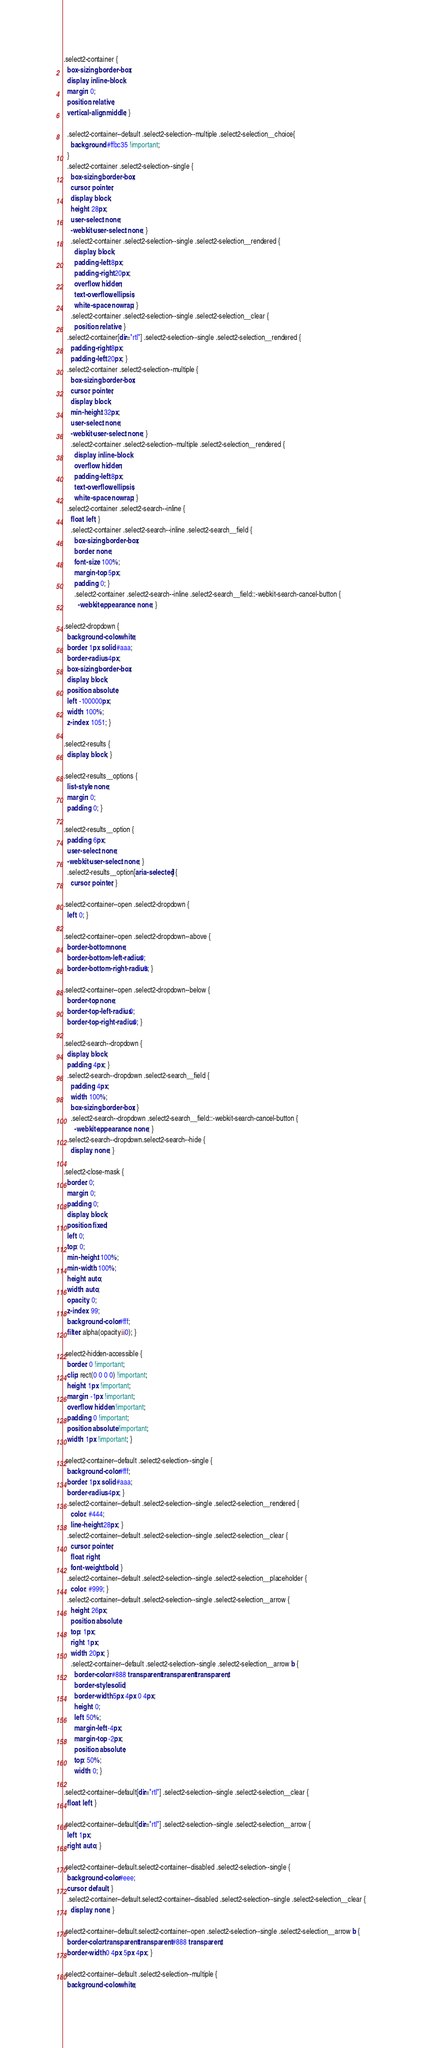Convert code to text. <code><loc_0><loc_0><loc_500><loc_500><_CSS_>.select2-container {
  box-sizing: border-box;
  display: inline-block;
  margin: 0;
  position: relative;
  vertical-align: middle; }

  .select2-container--default .select2-selection--multiple .select2-selection__choice{
    background: #ffbc35 !important;
  }
  .select2-container .select2-selection--single {
    box-sizing: border-box;
    cursor: pointer;
    display: block;
    height: 28px;
    user-select: none;
    -webkit-user-select: none; }
    .select2-container .select2-selection--single .select2-selection__rendered {
      display: block;
      padding-left: 8px;
      padding-right: 20px;
      overflow: hidden;
      text-overflow: ellipsis;
      white-space: nowrap; }
    .select2-container .select2-selection--single .select2-selection__clear {
      position: relative; }
  .select2-container[dir="rtl"] .select2-selection--single .select2-selection__rendered {
    padding-right: 8px;
    padding-left: 20px; }
  .select2-container .select2-selection--multiple {
    box-sizing: border-box;
    cursor: pointer;
    display: block;
    min-height: 32px;
    user-select: none;
    -webkit-user-select: none; }
    .select2-container .select2-selection--multiple .select2-selection__rendered {
      display: inline-block;
      overflow: hidden;
      padding-left: 8px;
      text-overflow: ellipsis;
      white-space: nowrap; }
  .select2-container .select2-search--inline {
    float: left; }
    .select2-container .select2-search--inline .select2-search__field {
      box-sizing: border-box;
      border: none;
      font-size: 100%;
      margin-top: 5px;
      padding: 0; }
      .select2-container .select2-search--inline .select2-search__field::-webkit-search-cancel-button {
        -webkit-appearance: none; }

.select2-dropdown {
  background-color: white;
  border: 1px solid #aaa;
  border-radius: 4px;
  box-sizing: border-box;
  display: block;
  position: absolute;
  left: -100000px;
  width: 100%;
  z-index: 1051; }

.select2-results {
  display: block; }

.select2-results__options {
  list-style: none;
  margin: 0;
  padding: 0; }

.select2-results__option {
  padding: 6px;
  user-select: none;
  -webkit-user-select: none; }
  .select2-results__option[aria-selected] {
    cursor: pointer; }

.select2-container--open .select2-dropdown {
  left: 0; }

.select2-container--open .select2-dropdown--above {
  border-bottom: none;
  border-bottom-left-radius: 0;
  border-bottom-right-radius: 0; }

.select2-container--open .select2-dropdown--below {
  border-top: none;
  border-top-left-radius: 0;
  border-top-right-radius: 0; }

.select2-search--dropdown {
  display: block;
  padding: 4px; }
  .select2-search--dropdown .select2-search__field {
    padding: 4px;
    width: 100%;
    box-sizing: border-box; }
    .select2-search--dropdown .select2-search__field::-webkit-search-cancel-button {
      -webkit-appearance: none; }
  .select2-search--dropdown.select2-search--hide {
    display: none; }

.select2-close-mask {
  border: 0;
  margin: 0;
  padding: 0;
  display: block;
  position: fixed;
  left: 0;
  top: 0;
  min-height: 100%;
  min-width: 100%;
  height: auto;
  width: auto;
  opacity: 0;
  z-index: 99;
  background-color: #fff;
  filter: alpha(opacity=0); }

.select2-hidden-accessible {
  border: 0 !important;
  clip: rect(0 0 0 0) !important;
  height: 1px !important;
  margin: -1px !important;
  overflow: hidden !important;
  padding: 0 !important;
  position: absolute !important;
  width: 1px !important; }

.select2-container--default .select2-selection--single {
  background-color: #fff;
  border: 1px solid #aaa;
  border-radius: 4px; }
  .select2-container--default .select2-selection--single .select2-selection__rendered {
    color: #444;
    line-height: 28px; }
  .select2-container--default .select2-selection--single .select2-selection__clear {
    cursor: pointer;
    float: right;
    font-weight: bold; }
  .select2-container--default .select2-selection--single .select2-selection__placeholder {
    color: #999; }
  .select2-container--default .select2-selection--single .select2-selection__arrow {
    height: 26px;
    position: absolute;
    top: 1px;
    right: 1px;
    width: 20px; }
    .select2-container--default .select2-selection--single .select2-selection__arrow b {
      border-color: #888 transparent transparent transparent;
      border-style: solid;
      border-width: 5px 4px 0 4px;
      height: 0;
      left: 50%;
      margin-left: -4px;
      margin-top: -2px;
      position: absolute;
      top: 50%;
      width: 0; }

.select2-container--default[dir="rtl"] .select2-selection--single .select2-selection__clear {
  float: left; }

.select2-container--default[dir="rtl"] .select2-selection--single .select2-selection__arrow {
  left: 1px;
  right: auto; }

.select2-container--default.select2-container--disabled .select2-selection--single {
  background-color: #eee;
  cursor: default; }
  .select2-container--default.select2-container--disabled .select2-selection--single .select2-selection__clear {
    display: none; }

.select2-container--default.select2-container--open .select2-selection--single .select2-selection__arrow b {
  border-color: transparent transparent #888 transparent;
  border-width: 0 4px 5px 4px; }

.select2-container--default .select2-selection--multiple {
  background-color: white;</code> 